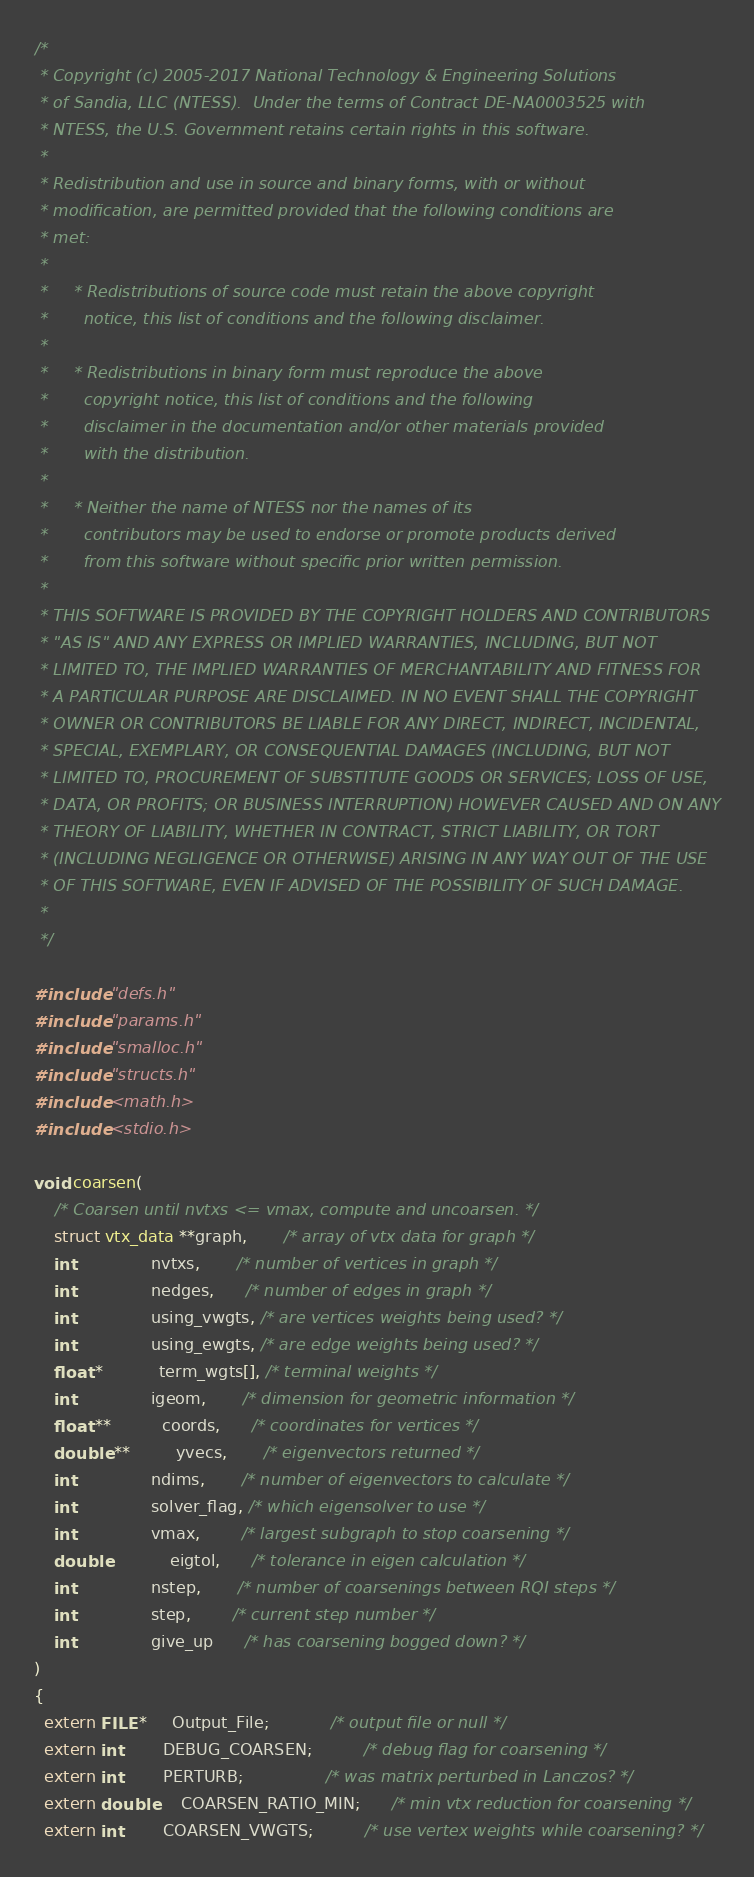Convert code to text. <code><loc_0><loc_0><loc_500><loc_500><_C_>/*
 * Copyright (c) 2005-2017 National Technology & Engineering Solutions
 * of Sandia, LLC (NTESS).  Under the terms of Contract DE-NA0003525 with
 * NTESS, the U.S. Government retains certain rights in this software.
 *
 * Redistribution and use in source and binary forms, with or without
 * modification, are permitted provided that the following conditions are
 * met:
 *
 *     * Redistributions of source code must retain the above copyright
 *       notice, this list of conditions and the following disclaimer.
 *
 *     * Redistributions in binary form must reproduce the above
 *       copyright notice, this list of conditions and the following
 *       disclaimer in the documentation and/or other materials provided
 *       with the distribution.
 *
 *     * Neither the name of NTESS nor the names of its
 *       contributors may be used to endorse or promote products derived
 *       from this software without specific prior written permission.
 *
 * THIS SOFTWARE IS PROVIDED BY THE COPYRIGHT HOLDERS AND CONTRIBUTORS
 * "AS IS" AND ANY EXPRESS OR IMPLIED WARRANTIES, INCLUDING, BUT NOT
 * LIMITED TO, THE IMPLIED WARRANTIES OF MERCHANTABILITY AND FITNESS FOR
 * A PARTICULAR PURPOSE ARE DISCLAIMED. IN NO EVENT SHALL THE COPYRIGHT
 * OWNER OR CONTRIBUTORS BE LIABLE FOR ANY DIRECT, INDIRECT, INCIDENTAL,
 * SPECIAL, EXEMPLARY, OR CONSEQUENTIAL DAMAGES (INCLUDING, BUT NOT
 * LIMITED TO, PROCUREMENT OF SUBSTITUTE GOODS OR SERVICES; LOSS OF USE,
 * DATA, OR PROFITS; OR BUSINESS INTERRUPTION) HOWEVER CAUSED AND ON ANY
 * THEORY OF LIABILITY, WHETHER IN CONTRACT, STRICT LIABILITY, OR TORT
 * (INCLUDING NEGLIGENCE OR OTHERWISE) ARISING IN ANY WAY OUT OF THE USE
 * OF THIS SOFTWARE, EVEN IF ADVISED OF THE POSSIBILITY OF SUCH DAMAGE.
 *
 */

#include "defs.h"
#include "params.h"
#include "smalloc.h"
#include "structs.h"
#include <math.h>
#include <stdio.h>

void coarsen(
    /* Coarsen until nvtxs <= vmax, compute and uncoarsen. */
    struct vtx_data **graph,       /* array of vtx data for graph */
    int               nvtxs,       /* number of vertices in graph */
    int               nedges,      /* number of edges in graph */
    int               using_vwgts, /* are vertices weights being used? */
    int               using_ewgts, /* are edge weights being used? */
    float *           term_wgts[], /* terminal weights */
    int               igeom,       /* dimension for geometric information */
    float **          coords,      /* coordinates for vertices */
    double **         yvecs,       /* eigenvectors returned */
    int               ndims,       /* number of eigenvectors to calculate */
    int               solver_flag, /* which eigensolver to use */
    int               vmax,        /* largest subgraph to stop coarsening */
    double            eigtol,      /* tolerance in eigen calculation */
    int               nstep,       /* number of coarsenings between RQI steps */
    int               step,        /* current step number */
    int               give_up      /* has coarsening bogged down? */
)
{
  extern FILE *     Output_File;            /* output file or null */
  extern int        DEBUG_COARSEN;          /* debug flag for coarsening */
  extern int        PERTURB;                /* was matrix perturbed in Lanczos? */
  extern double     COARSEN_RATIO_MIN;      /* min vtx reduction for coarsening */
  extern int        COARSEN_VWGTS;          /* use vertex weights while coarsening? */</code> 